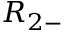<formula> <loc_0><loc_0><loc_500><loc_500>R _ { 2 - }</formula> 